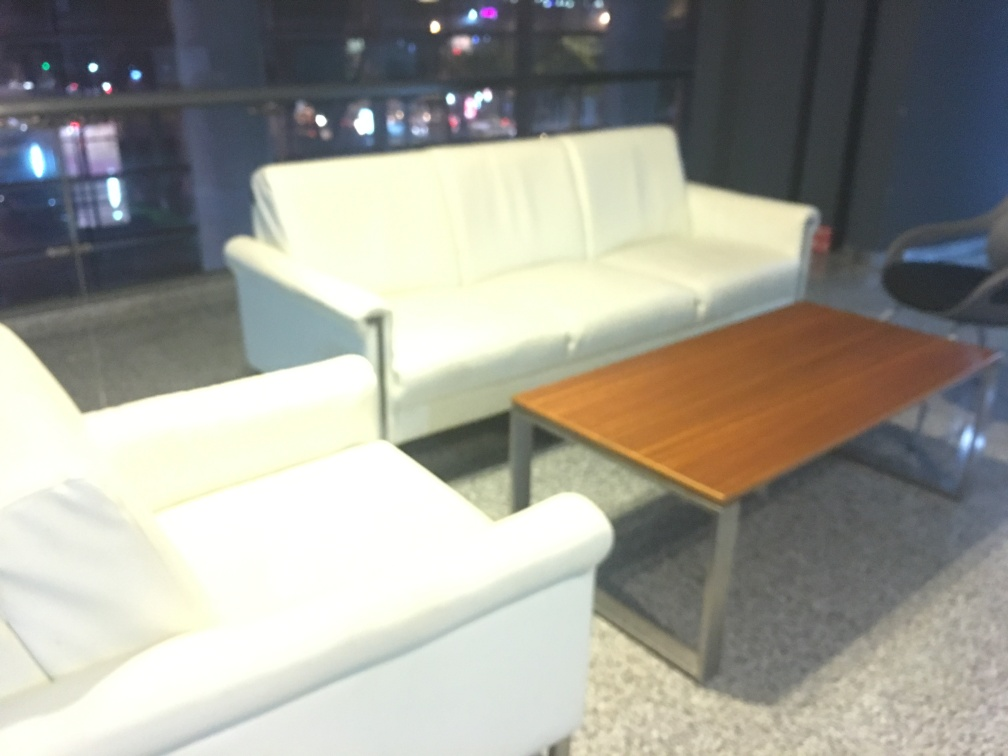Could you describe the style or design of the furniture in the picture? The furniture featured in the image showcases a contemporary style with minimalistic design. The couch and armchair boast clean lines and a streamlined form, with a white or light-colored upholstery that lends the pieces a modern and chic aesthetic. The coffee table has a classic wooden top with a simple yet sturdy metallic frame, suggesting functionality paired with style. This ensemble could fit well in a modern office space or a minimalist home interior. 